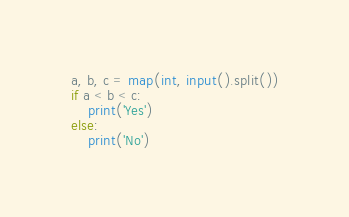<code> <loc_0><loc_0><loc_500><loc_500><_Python_>a, b, c = map(int, input().split())
if a < b < c:
    print('Yes')
else:
    print('No')
</code> 